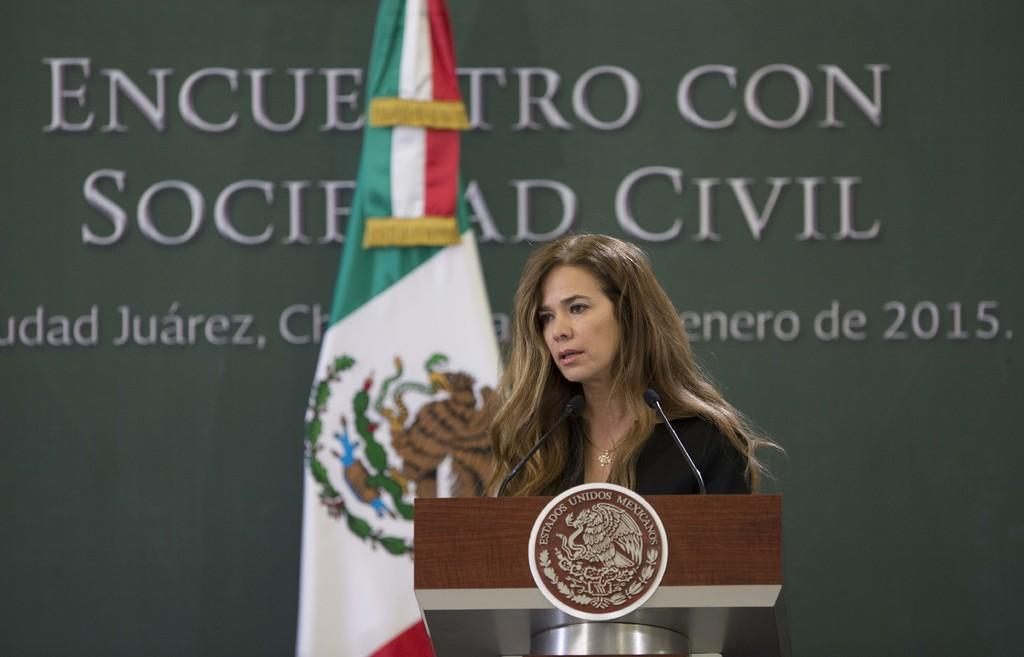Who is present in the image? There is a woman in the image. What object can be seen in front of the woman? There is a podium in the image. What is the flag associated with? The flag is present in the image. What can be seen on the board in the background of the image? There is a board with text in the background of the image. Where is the faucet located in the image? There is no faucet present in the image. Is the woman wearing a ring in the image? The provided facts do not mention a ring, so we cannot determine if the woman is wearing one. Can you see a squirrel in the image? There is no squirrel present in the image. 